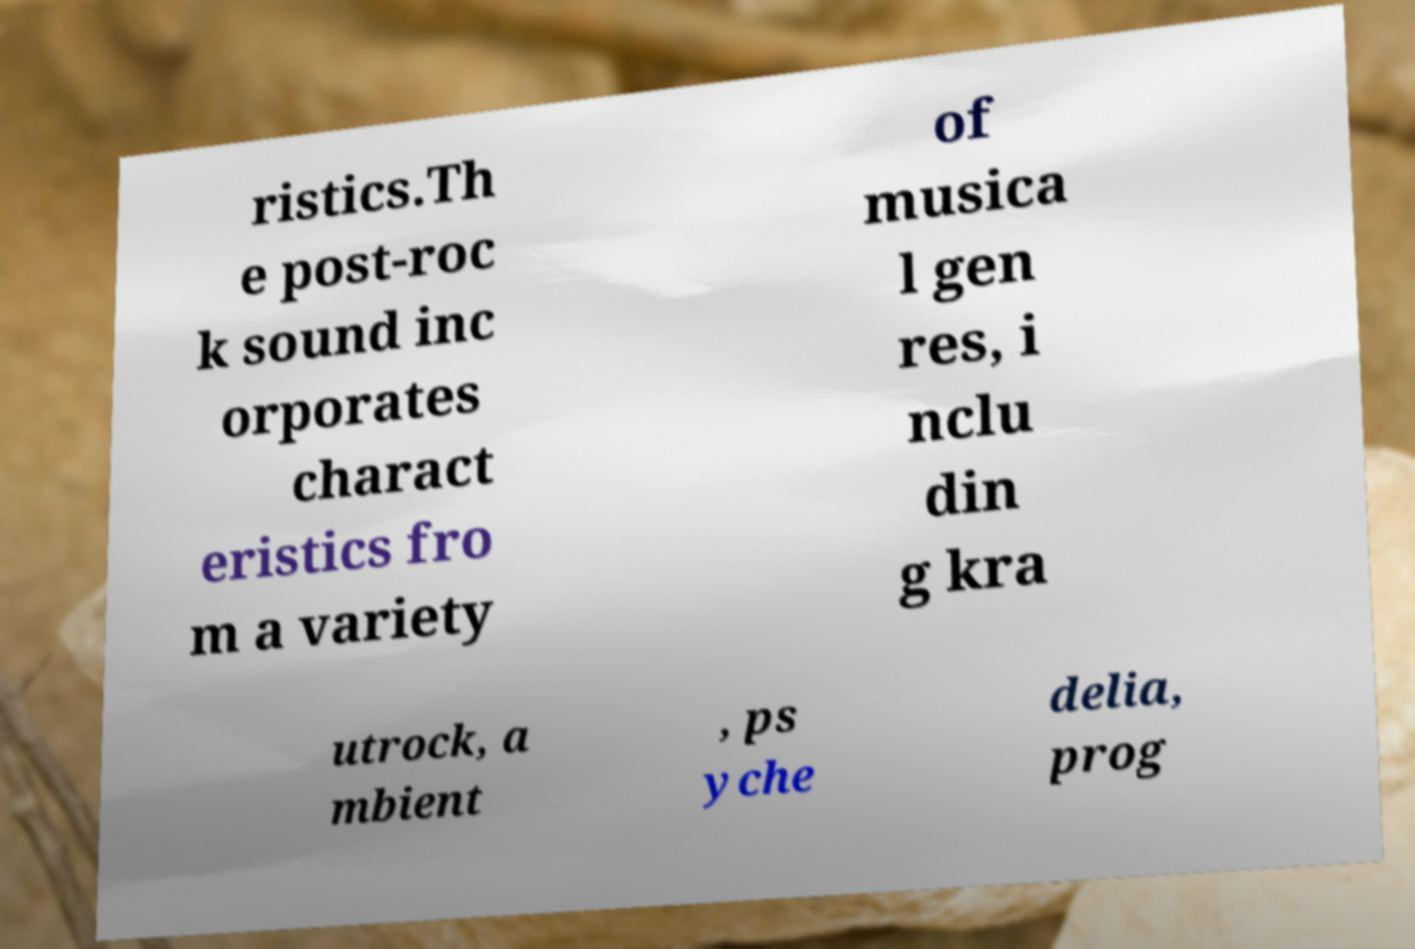Can you read and provide the text displayed in the image?This photo seems to have some interesting text. Can you extract and type it out for me? ristics.Th e post-roc k sound inc orporates charact eristics fro m a variety of musica l gen res, i nclu din g kra utrock, a mbient , ps yche delia, prog 